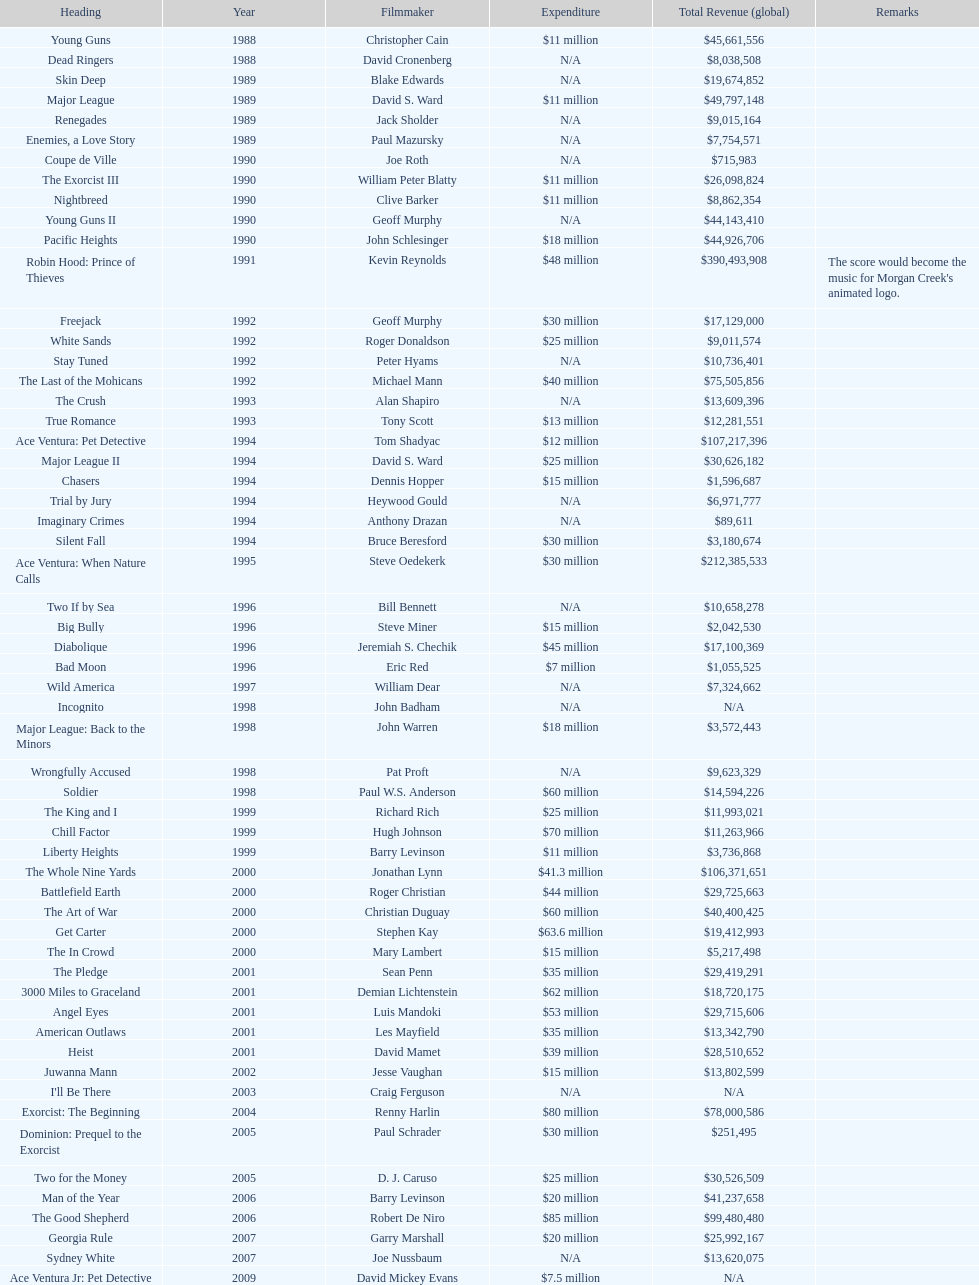Which morgan creek film grossed the most money prior to 1994? Robin Hood: Prince of Thieves. Could you parse the entire table as a dict? {'header': ['Heading', 'Year', 'Filmmaker', 'Expenditure', 'Total Revenue (global)', 'Remarks'], 'rows': [['Young Guns', '1988', 'Christopher Cain', '$11 million', '$45,661,556', ''], ['Dead Ringers', '1988', 'David Cronenberg', 'N/A', '$8,038,508', ''], ['Skin Deep', '1989', 'Blake Edwards', 'N/A', '$19,674,852', ''], ['Major League', '1989', 'David S. Ward', '$11 million', '$49,797,148', ''], ['Renegades', '1989', 'Jack Sholder', 'N/A', '$9,015,164', ''], ['Enemies, a Love Story', '1989', 'Paul Mazursky', 'N/A', '$7,754,571', ''], ['Coupe de Ville', '1990', 'Joe Roth', 'N/A', '$715,983', ''], ['The Exorcist III', '1990', 'William Peter Blatty', '$11 million', '$26,098,824', ''], ['Nightbreed', '1990', 'Clive Barker', '$11 million', '$8,862,354', ''], ['Young Guns II', '1990', 'Geoff Murphy', 'N/A', '$44,143,410', ''], ['Pacific Heights', '1990', 'John Schlesinger', '$18 million', '$44,926,706', ''], ['Robin Hood: Prince of Thieves', '1991', 'Kevin Reynolds', '$48 million', '$390,493,908', "The score would become the music for Morgan Creek's animated logo."], ['Freejack', '1992', 'Geoff Murphy', '$30 million', '$17,129,000', ''], ['White Sands', '1992', 'Roger Donaldson', '$25 million', '$9,011,574', ''], ['Stay Tuned', '1992', 'Peter Hyams', 'N/A', '$10,736,401', ''], ['The Last of the Mohicans', '1992', 'Michael Mann', '$40 million', '$75,505,856', ''], ['The Crush', '1993', 'Alan Shapiro', 'N/A', '$13,609,396', ''], ['True Romance', '1993', 'Tony Scott', '$13 million', '$12,281,551', ''], ['Ace Ventura: Pet Detective', '1994', 'Tom Shadyac', '$12 million', '$107,217,396', ''], ['Major League II', '1994', 'David S. Ward', '$25 million', '$30,626,182', ''], ['Chasers', '1994', 'Dennis Hopper', '$15 million', '$1,596,687', ''], ['Trial by Jury', '1994', 'Heywood Gould', 'N/A', '$6,971,777', ''], ['Imaginary Crimes', '1994', 'Anthony Drazan', 'N/A', '$89,611', ''], ['Silent Fall', '1994', 'Bruce Beresford', '$30 million', '$3,180,674', ''], ['Ace Ventura: When Nature Calls', '1995', 'Steve Oedekerk', '$30 million', '$212,385,533', ''], ['Two If by Sea', '1996', 'Bill Bennett', 'N/A', '$10,658,278', ''], ['Big Bully', '1996', 'Steve Miner', '$15 million', '$2,042,530', ''], ['Diabolique', '1996', 'Jeremiah S. Chechik', '$45 million', '$17,100,369', ''], ['Bad Moon', '1996', 'Eric Red', '$7 million', '$1,055,525', ''], ['Wild America', '1997', 'William Dear', 'N/A', '$7,324,662', ''], ['Incognito', '1998', 'John Badham', 'N/A', 'N/A', ''], ['Major League: Back to the Minors', '1998', 'John Warren', '$18 million', '$3,572,443', ''], ['Wrongfully Accused', '1998', 'Pat Proft', 'N/A', '$9,623,329', ''], ['Soldier', '1998', 'Paul W.S. Anderson', '$60 million', '$14,594,226', ''], ['The King and I', '1999', 'Richard Rich', '$25 million', '$11,993,021', ''], ['Chill Factor', '1999', 'Hugh Johnson', '$70 million', '$11,263,966', ''], ['Liberty Heights', '1999', 'Barry Levinson', '$11 million', '$3,736,868', ''], ['The Whole Nine Yards', '2000', 'Jonathan Lynn', '$41.3 million', '$106,371,651', ''], ['Battlefield Earth', '2000', 'Roger Christian', '$44 million', '$29,725,663', ''], ['The Art of War', '2000', 'Christian Duguay', '$60 million', '$40,400,425', ''], ['Get Carter', '2000', 'Stephen Kay', '$63.6 million', '$19,412,993', ''], ['The In Crowd', '2000', 'Mary Lambert', '$15 million', '$5,217,498', ''], ['The Pledge', '2001', 'Sean Penn', '$35 million', '$29,419,291', ''], ['3000 Miles to Graceland', '2001', 'Demian Lichtenstein', '$62 million', '$18,720,175', ''], ['Angel Eyes', '2001', 'Luis Mandoki', '$53 million', '$29,715,606', ''], ['American Outlaws', '2001', 'Les Mayfield', '$35 million', '$13,342,790', ''], ['Heist', '2001', 'David Mamet', '$39 million', '$28,510,652', ''], ['Juwanna Mann', '2002', 'Jesse Vaughan', '$15 million', '$13,802,599', ''], ["I'll Be There", '2003', 'Craig Ferguson', 'N/A', 'N/A', ''], ['Exorcist: The Beginning', '2004', 'Renny Harlin', '$80 million', '$78,000,586', ''], ['Dominion: Prequel to the Exorcist', '2005', 'Paul Schrader', '$30 million', '$251,495', ''], ['Two for the Money', '2005', 'D. J. Caruso', '$25 million', '$30,526,509', ''], ['Man of the Year', '2006', 'Barry Levinson', '$20 million', '$41,237,658', ''], ['The Good Shepherd', '2006', 'Robert De Niro', '$85 million', '$99,480,480', ''], ['Georgia Rule', '2007', 'Garry Marshall', '$20 million', '$25,992,167', ''], ['Sydney White', '2007', 'Joe Nussbaum', 'N/A', '$13,620,075', ''], ['Ace Ventura Jr: Pet Detective', '2009', 'David Mickey Evans', '$7.5 million', 'N/A', ''], ['Dream House', '2011', 'Jim Sheridan', '$50 million', '$38,502,340', ''], ['The Thing', '2011', 'Matthijs van Heijningen Jr.', '$38 million', '$27,428,670', ''], ['Tupac', '2014', 'Antoine Fuqua', '$45 million', '', '']]} 